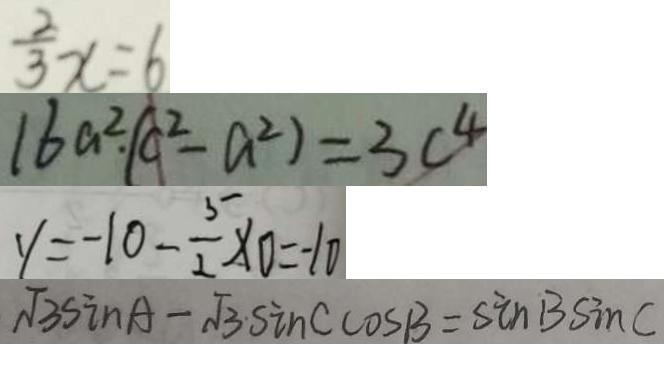Convert formula to latex. <formula><loc_0><loc_0><loc_500><loc_500>\frac { 2 } { 3 } x = 6 
 1 6 a ^ { 2 } \cdot ( c ^ { 2 } - a ^ { 2 } ) = 3 c ^ { 4 } 
 y = - 1 0 - \frac { 5 } { 2 } \times 0 = - 1 0 
 \sqrt { 3 } \sin A - \sqrt { 3 } \cdot \sin C \cos B = \sin B \sin C</formula> 